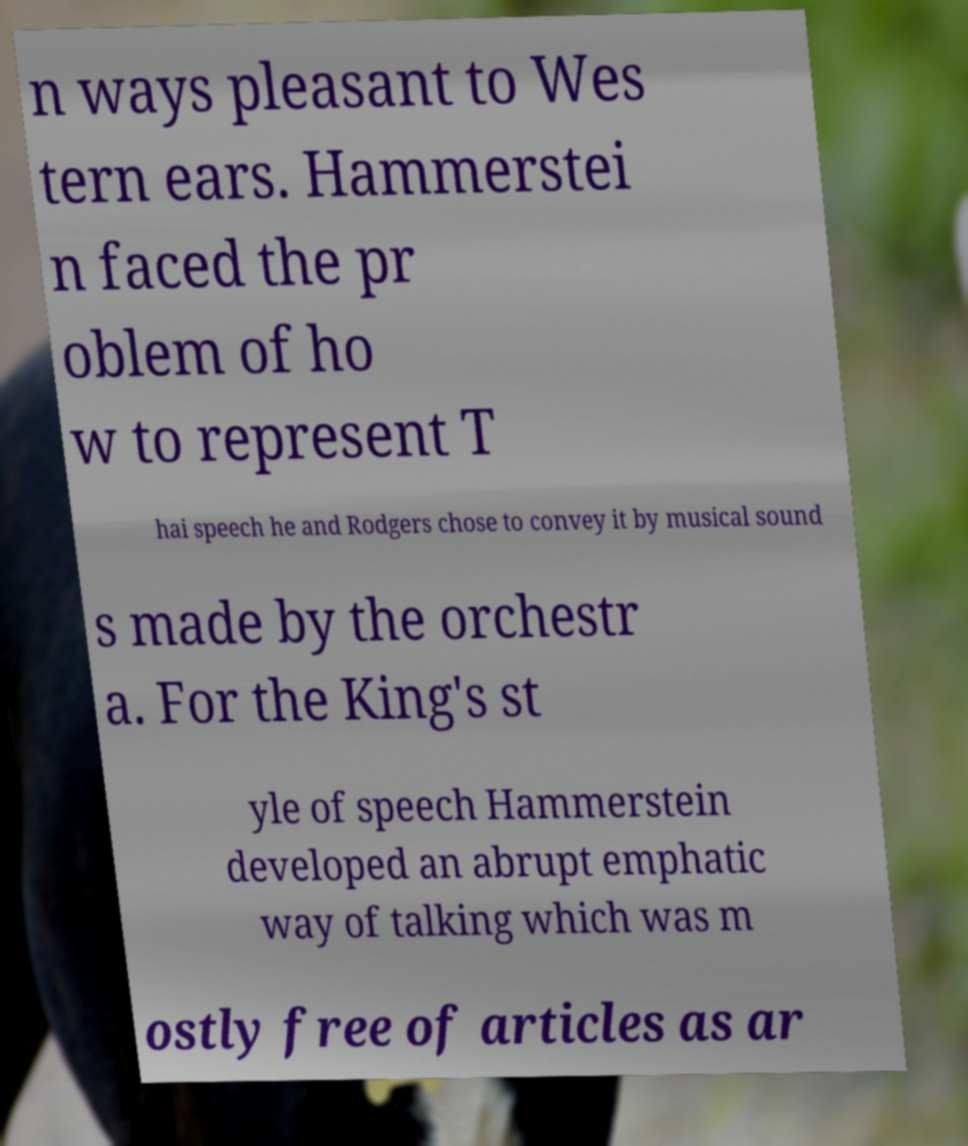Could you assist in decoding the text presented in this image and type it out clearly? n ways pleasant to Wes tern ears. Hammerstei n faced the pr oblem of ho w to represent T hai speech he and Rodgers chose to convey it by musical sound s made by the orchestr a. For the King's st yle of speech Hammerstein developed an abrupt emphatic way of talking which was m ostly free of articles as ar 